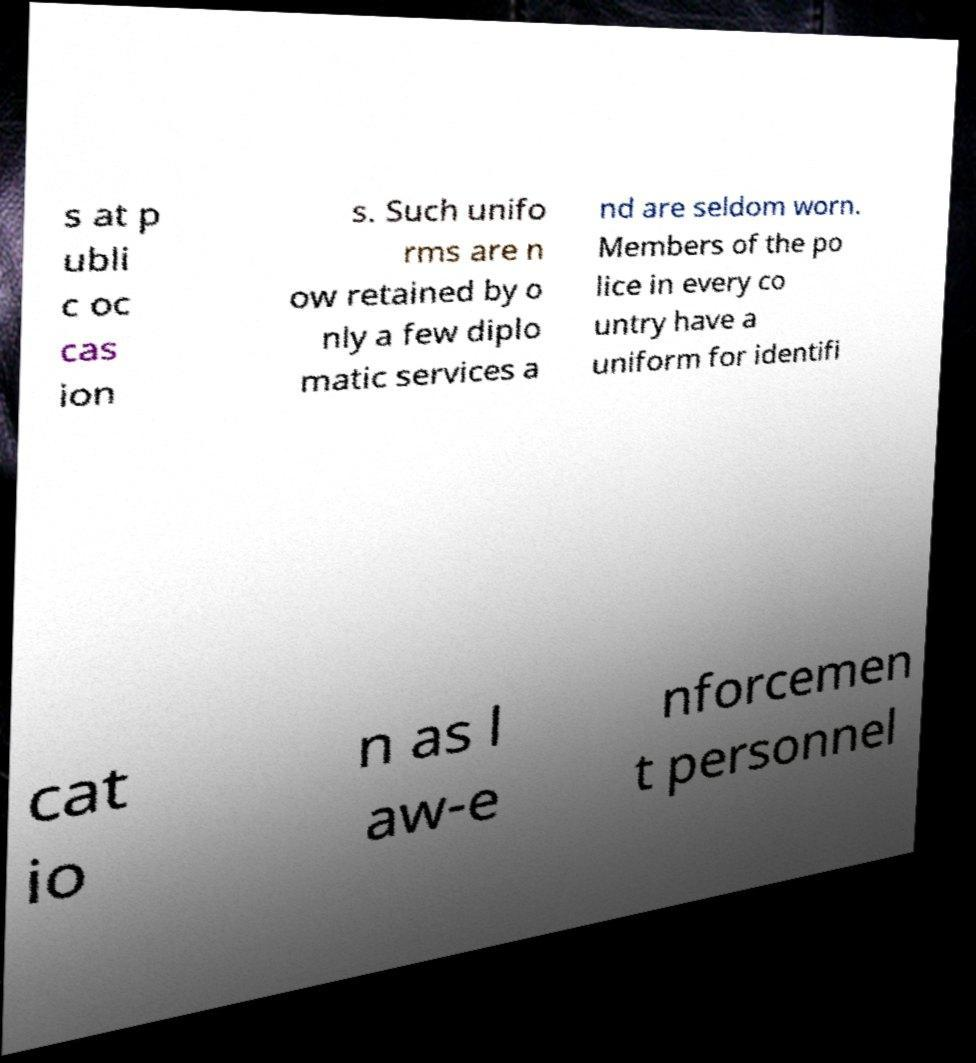Could you extract and type out the text from this image? s at p ubli c oc cas ion s. Such unifo rms are n ow retained by o nly a few diplo matic services a nd are seldom worn. Members of the po lice in every co untry have a uniform for identifi cat io n as l aw-e nforcemen t personnel 